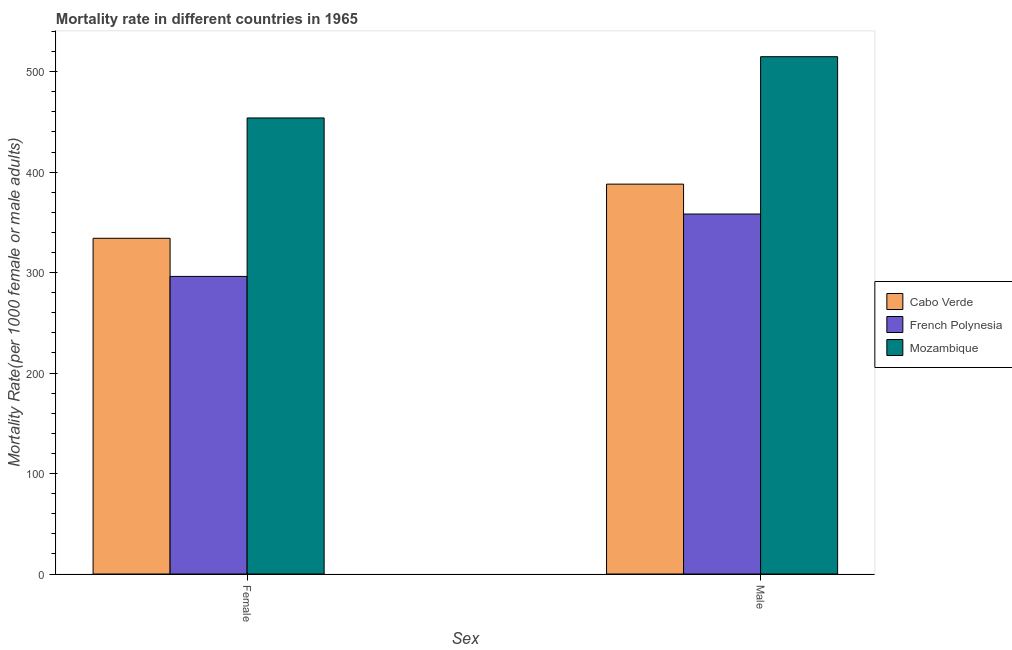How many different coloured bars are there?
Provide a short and direct response. 3. Are the number of bars per tick equal to the number of legend labels?
Your response must be concise. Yes. How many bars are there on the 1st tick from the left?
Your answer should be compact. 3. How many bars are there on the 1st tick from the right?
Keep it short and to the point. 3. What is the male mortality rate in French Polynesia?
Your answer should be very brief. 358.32. Across all countries, what is the maximum female mortality rate?
Your response must be concise. 453.93. Across all countries, what is the minimum male mortality rate?
Make the answer very short. 358.32. In which country was the female mortality rate maximum?
Give a very brief answer. Mozambique. In which country was the female mortality rate minimum?
Offer a very short reply. French Polynesia. What is the total male mortality rate in the graph?
Keep it short and to the point. 1261.32. What is the difference between the male mortality rate in Mozambique and that in French Polynesia?
Your answer should be compact. 156.61. What is the difference between the male mortality rate in Cabo Verde and the female mortality rate in French Polynesia?
Provide a short and direct response. 91.86. What is the average female mortality rate per country?
Offer a very short reply. 361.43. What is the difference between the female mortality rate and male mortality rate in Mozambique?
Keep it short and to the point. -60.99. In how many countries, is the female mortality rate greater than 180 ?
Give a very brief answer. 3. What is the ratio of the male mortality rate in Cabo Verde to that in Mozambique?
Offer a very short reply. 0.75. What does the 2nd bar from the left in Male represents?
Your answer should be very brief. French Polynesia. What does the 3rd bar from the right in Male represents?
Make the answer very short. Cabo Verde. Are all the bars in the graph horizontal?
Keep it short and to the point. No. How many countries are there in the graph?
Offer a very short reply. 3. What is the difference between two consecutive major ticks on the Y-axis?
Your answer should be compact. 100. Are the values on the major ticks of Y-axis written in scientific E-notation?
Provide a succinct answer. No. How many legend labels are there?
Ensure brevity in your answer.  3. What is the title of the graph?
Keep it short and to the point. Mortality rate in different countries in 1965. What is the label or title of the X-axis?
Your response must be concise. Sex. What is the label or title of the Y-axis?
Your response must be concise. Mortality Rate(per 1000 female or male adults). What is the Mortality Rate(per 1000 female or male adults) in Cabo Verde in Female?
Your response must be concise. 334.16. What is the Mortality Rate(per 1000 female or male adults) in French Polynesia in Female?
Ensure brevity in your answer.  296.21. What is the Mortality Rate(per 1000 female or male adults) of Mozambique in Female?
Keep it short and to the point. 453.93. What is the Mortality Rate(per 1000 female or male adults) in Cabo Verde in Male?
Provide a succinct answer. 388.08. What is the Mortality Rate(per 1000 female or male adults) of French Polynesia in Male?
Your answer should be compact. 358.32. What is the Mortality Rate(per 1000 female or male adults) in Mozambique in Male?
Ensure brevity in your answer.  514.92. Across all Sex, what is the maximum Mortality Rate(per 1000 female or male adults) of Cabo Verde?
Your answer should be very brief. 388.08. Across all Sex, what is the maximum Mortality Rate(per 1000 female or male adults) in French Polynesia?
Your response must be concise. 358.32. Across all Sex, what is the maximum Mortality Rate(per 1000 female or male adults) of Mozambique?
Give a very brief answer. 514.92. Across all Sex, what is the minimum Mortality Rate(per 1000 female or male adults) of Cabo Verde?
Your answer should be very brief. 334.16. Across all Sex, what is the minimum Mortality Rate(per 1000 female or male adults) in French Polynesia?
Ensure brevity in your answer.  296.21. Across all Sex, what is the minimum Mortality Rate(per 1000 female or male adults) in Mozambique?
Give a very brief answer. 453.93. What is the total Mortality Rate(per 1000 female or male adults) in Cabo Verde in the graph?
Provide a short and direct response. 722.24. What is the total Mortality Rate(per 1000 female or male adults) of French Polynesia in the graph?
Offer a very short reply. 654.53. What is the total Mortality Rate(per 1000 female or male adults) of Mozambique in the graph?
Ensure brevity in your answer.  968.86. What is the difference between the Mortality Rate(per 1000 female or male adults) in Cabo Verde in Female and that in Male?
Ensure brevity in your answer.  -53.92. What is the difference between the Mortality Rate(per 1000 female or male adults) in French Polynesia in Female and that in Male?
Provide a short and direct response. -62.1. What is the difference between the Mortality Rate(per 1000 female or male adults) in Mozambique in Female and that in Male?
Offer a terse response. -60.99. What is the difference between the Mortality Rate(per 1000 female or male adults) in Cabo Verde in Female and the Mortality Rate(per 1000 female or male adults) in French Polynesia in Male?
Your answer should be compact. -24.16. What is the difference between the Mortality Rate(per 1000 female or male adults) of Cabo Verde in Female and the Mortality Rate(per 1000 female or male adults) of Mozambique in Male?
Your answer should be compact. -180.77. What is the difference between the Mortality Rate(per 1000 female or male adults) of French Polynesia in Female and the Mortality Rate(per 1000 female or male adults) of Mozambique in Male?
Offer a terse response. -218.71. What is the average Mortality Rate(per 1000 female or male adults) of Cabo Verde per Sex?
Offer a terse response. 361.12. What is the average Mortality Rate(per 1000 female or male adults) of French Polynesia per Sex?
Your answer should be compact. 327.27. What is the average Mortality Rate(per 1000 female or male adults) of Mozambique per Sex?
Your answer should be compact. 484.43. What is the difference between the Mortality Rate(per 1000 female or male adults) of Cabo Verde and Mortality Rate(per 1000 female or male adults) of French Polynesia in Female?
Make the answer very short. 37.95. What is the difference between the Mortality Rate(per 1000 female or male adults) in Cabo Verde and Mortality Rate(per 1000 female or male adults) in Mozambique in Female?
Offer a very short reply. -119.77. What is the difference between the Mortality Rate(per 1000 female or male adults) in French Polynesia and Mortality Rate(per 1000 female or male adults) in Mozambique in Female?
Keep it short and to the point. -157.72. What is the difference between the Mortality Rate(per 1000 female or male adults) of Cabo Verde and Mortality Rate(per 1000 female or male adults) of French Polynesia in Male?
Ensure brevity in your answer.  29.76. What is the difference between the Mortality Rate(per 1000 female or male adults) of Cabo Verde and Mortality Rate(per 1000 female or male adults) of Mozambique in Male?
Your answer should be very brief. -126.85. What is the difference between the Mortality Rate(per 1000 female or male adults) in French Polynesia and Mortality Rate(per 1000 female or male adults) in Mozambique in Male?
Offer a terse response. -156.61. What is the ratio of the Mortality Rate(per 1000 female or male adults) in Cabo Verde in Female to that in Male?
Your answer should be very brief. 0.86. What is the ratio of the Mortality Rate(per 1000 female or male adults) of French Polynesia in Female to that in Male?
Offer a very short reply. 0.83. What is the ratio of the Mortality Rate(per 1000 female or male adults) of Mozambique in Female to that in Male?
Make the answer very short. 0.88. What is the difference between the highest and the second highest Mortality Rate(per 1000 female or male adults) of Cabo Verde?
Provide a short and direct response. 53.92. What is the difference between the highest and the second highest Mortality Rate(per 1000 female or male adults) of French Polynesia?
Give a very brief answer. 62.1. What is the difference between the highest and the second highest Mortality Rate(per 1000 female or male adults) in Mozambique?
Ensure brevity in your answer.  60.99. What is the difference between the highest and the lowest Mortality Rate(per 1000 female or male adults) of Cabo Verde?
Offer a terse response. 53.92. What is the difference between the highest and the lowest Mortality Rate(per 1000 female or male adults) in French Polynesia?
Make the answer very short. 62.1. What is the difference between the highest and the lowest Mortality Rate(per 1000 female or male adults) in Mozambique?
Give a very brief answer. 60.99. 